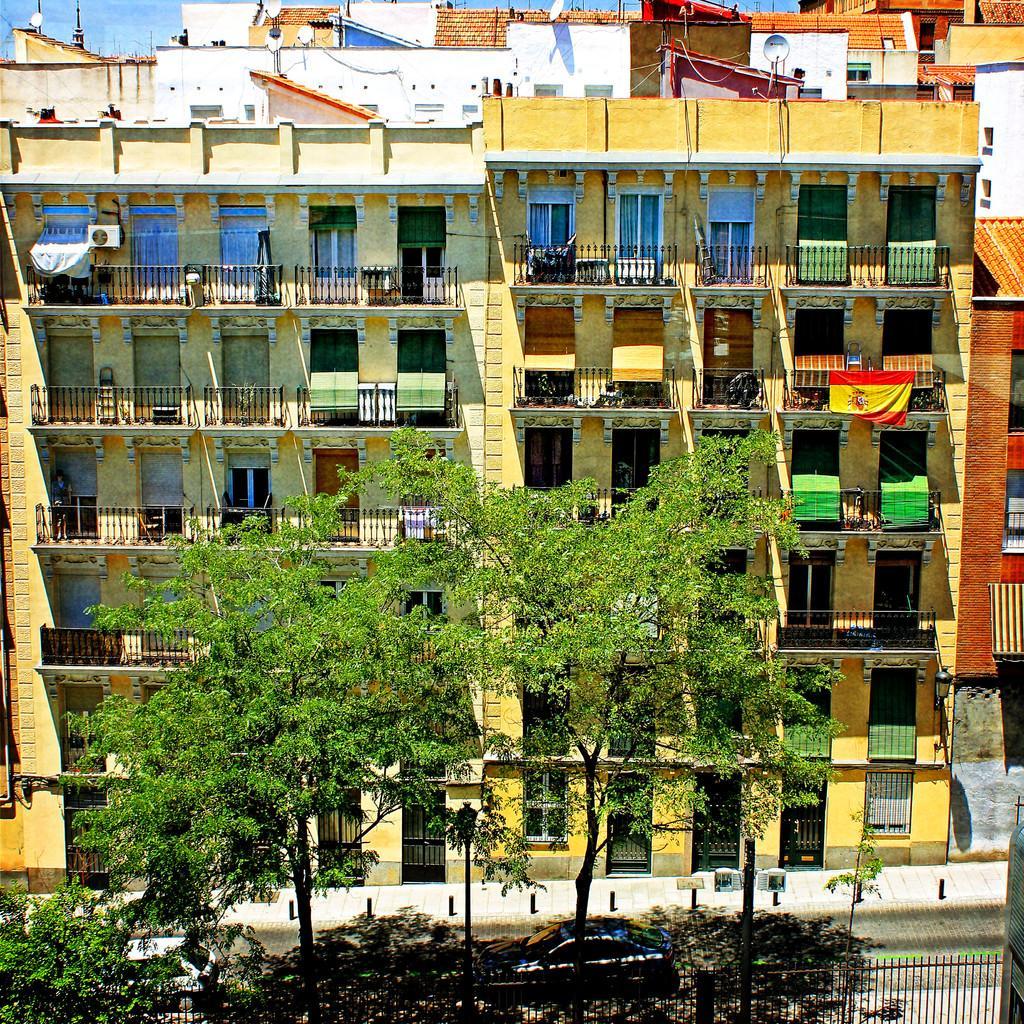How would you summarize this image in a sentence or two? In this image there are buildings and trees. At the bottom there is a fence and we can see cars on the road. In the background there is sky. 